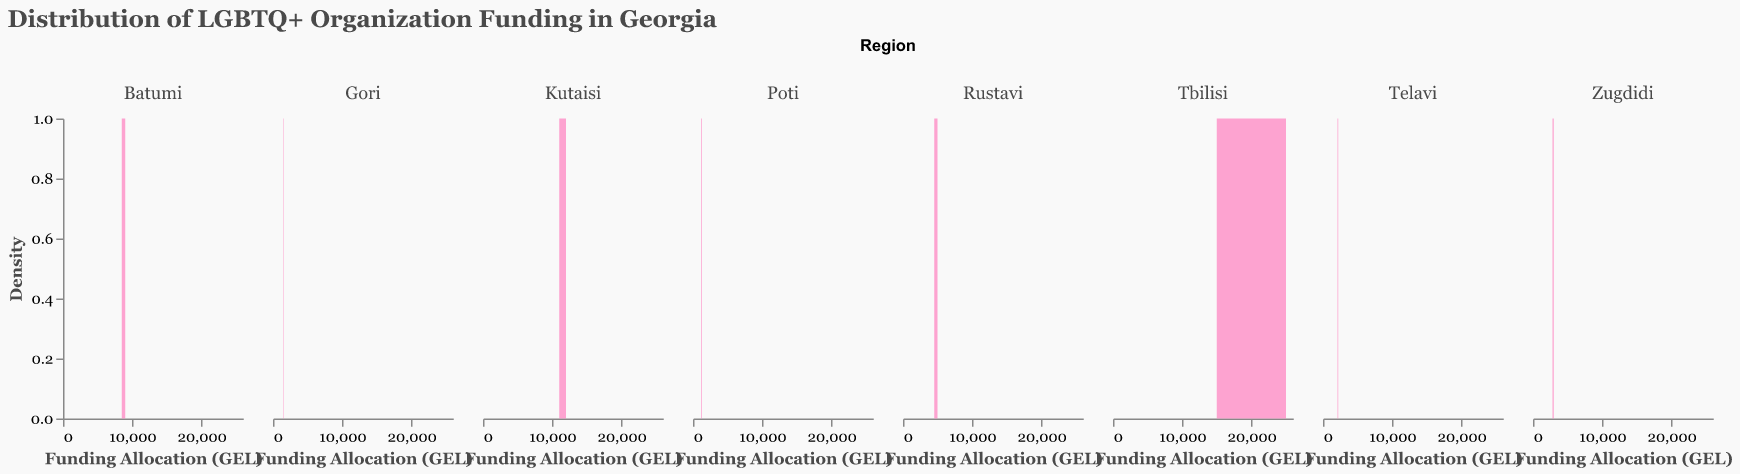How is the title of the figure phrased? The title of the figure is explicitly written at the top.
Answer: "Distribution of LGBTQ+ Organization Funding in Georgia" Which region in Georgia has the highest overall funding allocation for LGBTQ+ organizations? By looking at the plot, Tbilisi appears to have the highest peaks, implying a greater number of funding allocations.
Answer: Tbilisi What is the common funding range (in GEL) for organizations in Rustavi? The density plot for Rustavi shows peaks mainly between 4000 and 5000 GEL.
Answer: 4000 - 5000 GEL Compare the median funding allocations for organizations in Batumi and Kutaisi. Which city has a higher median allocation? For Batumi, the peak funding ranges around 8500-9000 GEL, and for Kutaisi, it ranges around 11000-12000 GEL.
Answer: Kutaisi Which region has the smallest overall funding for LGBTQ+ organizations? Zugdidi shows the lowest peaks in its density plot, indicating smaller funding allocations compared to other regions.
Answer: Zugdidi What is the density that represents the most frequent funding allocation for LGBTQ+ organizations in Kutaisi? The highest density peak in Kutaisi can be identified visually and corresponds to the amount around 12000 GEL.
Answer: Around 12000 GEL Given the density plots, which region has the most variation in funding allocations? Gori's density plot has a broader range and lower peaks, indicating a wide variation in funding compared to other regions.
Answer: Gori Does Poti have any funding allocations above 1500 GEL? Poti's density peaks just below 1500, indicating there are no allocations above this amount.
Answer: No What percentage of funding allocations in Tbilisi fall above 20000 GEL? Observing the plot, a significant peak is seen at 25000 GEL, which represents a large portion of the data for Tbilisi. Hence, approximately half the funding allocations in Tbilisi fall above 20000 GEL.
Answer: Approximately 50% Compare Tbilisi and Batumi: which region has a higher frequency of funding allocations below 10000 GEL? Tbilisi has lower density below 10000 GEL compared to Batumi, where most peaks are below 10000 GEL.
Answer: Batumi 